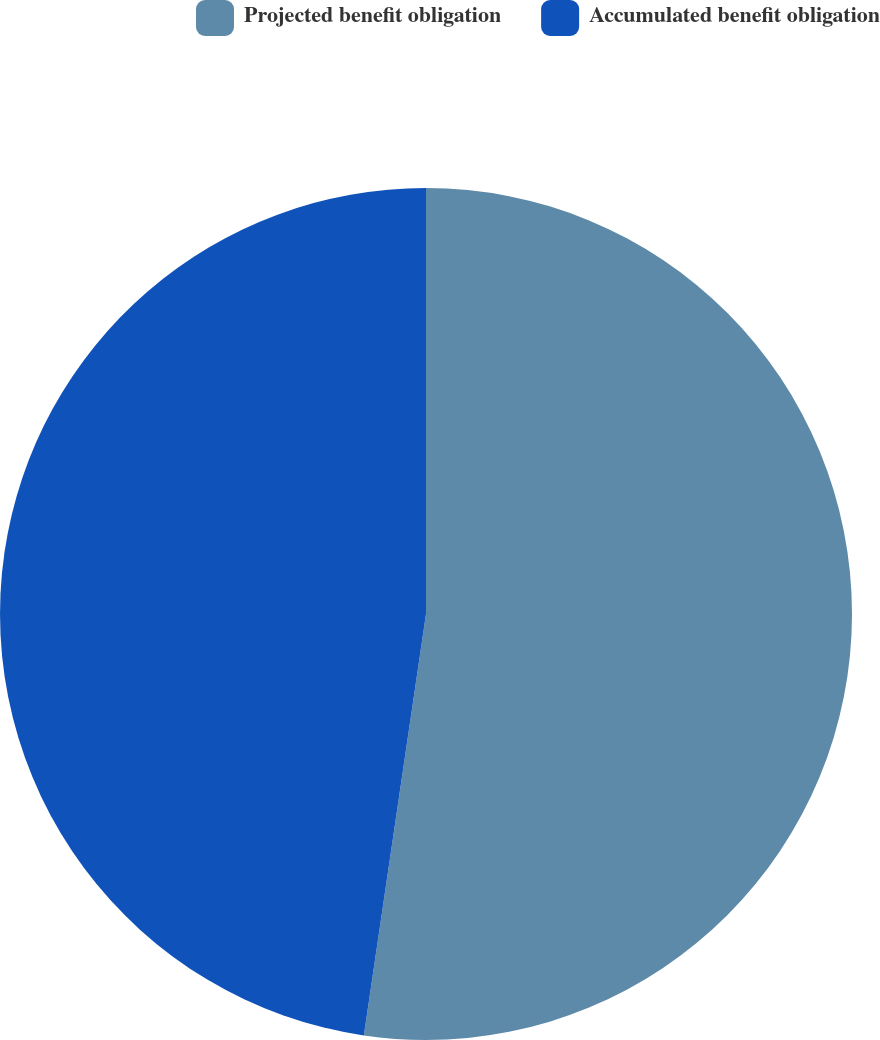Convert chart to OTSL. <chart><loc_0><loc_0><loc_500><loc_500><pie_chart><fcel>Projected benefit obligation<fcel>Accumulated benefit obligation<nl><fcel>52.33%<fcel>47.67%<nl></chart> 